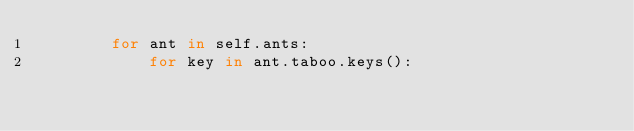Convert code to text. <code><loc_0><loc_0><loc_500><loc_500><_Python_>        for ant in self.ants:
            for key in ant.taboo.keys():</code> 